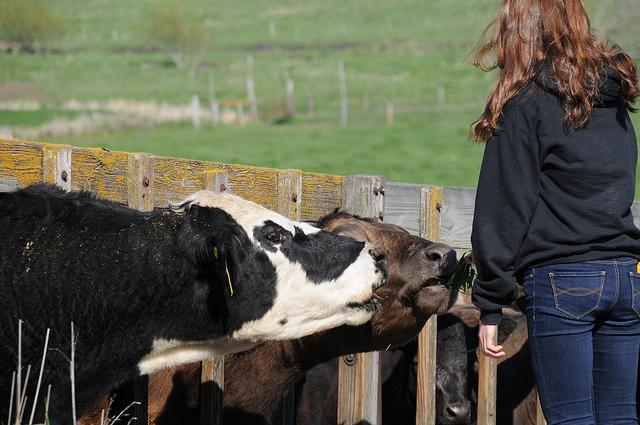Who is the woman feeding the cows? Please explain your reasoning. visitor. The woman is just a visitor. 